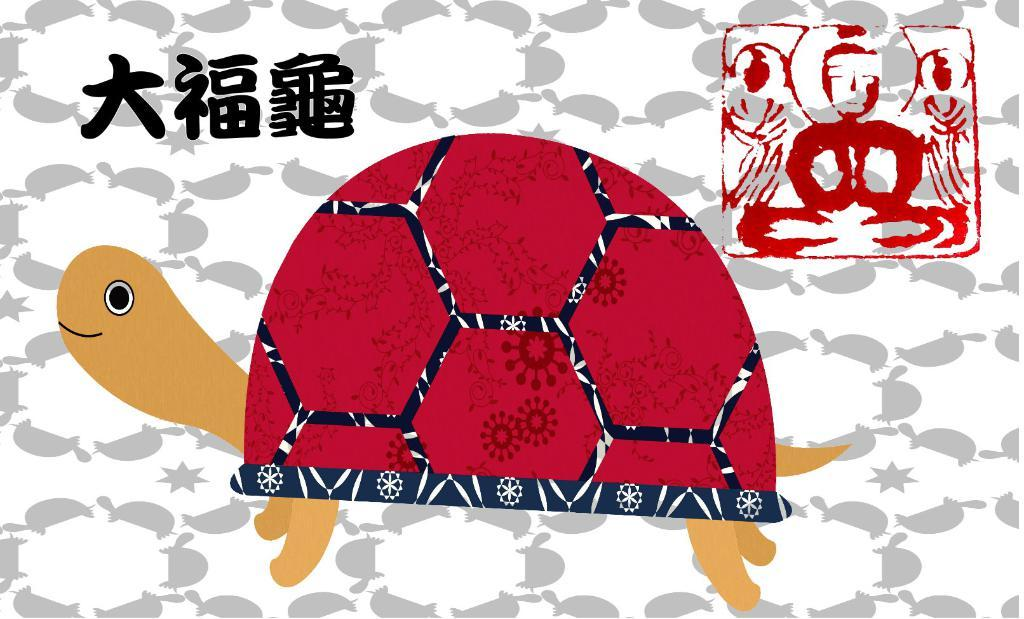What is the main subject of the painting in the image? The painting features a tortoise. Are there any words or letters in the painting? Yes, there is text in the painting. What can be seen behind the tortoise in the painting? There is a background with a design in the image. What type of hammer is being used to paint the tortoise in the image? There is no hammer present in the image; the painting is a static image and does not depict the process of creating the painting. 